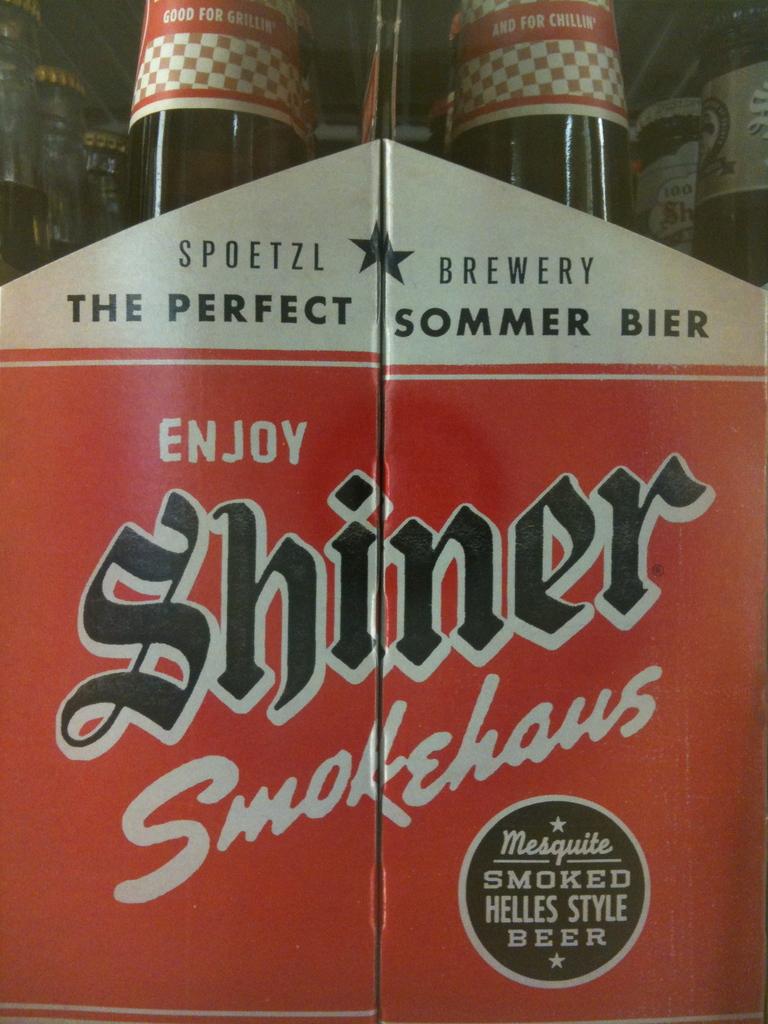What beer is this?
Provide a succinct answer. Shiner. What is the name of the brewery?
Your response must be concise. Shiner. 